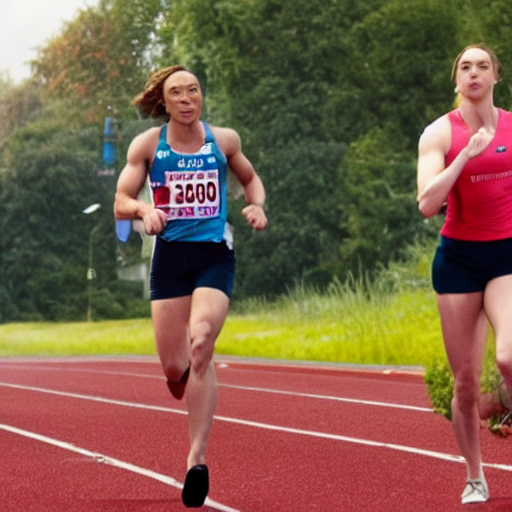What indications are there regarding the location and occasion of this event? The image shows a well-maintained red running track that indicates an organized athletic event, likely a track meet. The presence of markers such as lane numbers on the track and athletes wearing bibs with numbers and sponsors point to a formal competition, possibly at a professional or collegiate level. The lush greenery in the background could suggest the event is taking place in an open-air stadium surrounded by natural landscapes, often typical of outdoor athletic complexes. 